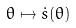Convert formula to latex. <formula><loc_0><loc_0><loc_500><loc_500>\theta \mapsto \dot { s } ( \theta )</formula> 